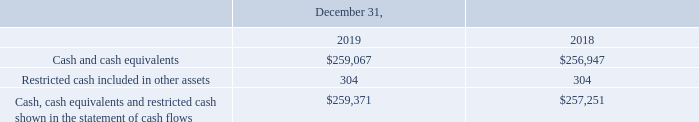Cash, Cash Equivalents and Restricted Cash
As of December 31, 2019, the Company had $259.1 million of cash and cash equivalents. Cash and cash equivalents include liquid investments, primarily money market funds, with maturities of less than 90 days at the time of purchase. Management determines the appropriate classification of its investments at the time of purchase and at each balance sheet date.
As of December 31, 2019 and December 31, 2018, the Company had restricted cash of $0.3 million, representing the amount pledged as collateral to the issuer of a standby letter of credit (the “LC”). The LC, which expires in August 2021, has been provided as a guaranty to the lessor of our corporate offices.
The following table provides a reconciliation of cash, cash equivalents and restricted cash reported within the consolidated balance sheet to the consolidated statement of cash flows (in thousands):
What are the respective cash and cash equivalents in 2018 and 2019?
Answer scale should be: thousand. $256,947, $259,067. What are the respective restricted cash included in other assets in 2018 and 2019?
Answer scale should be: thousand. 304, 304. What are the respective cash, cash equivalents and restricted cash shown in the statement of cash flows in 2018 and 2019?
Answer scale should be: thousand. $257,251, $259,371. What is the average cash and cash equivalents in 2018 and 2019?
Answer scale should be: thousand. ($259,067 + $256,947)/2 
Answer: 258007. What is the percentage change in cash and cash equivalents between 2018 and 2019?
Answer scale should be: percent. (259,067 - 256,947)/256,947 
Answer: 0.83. What is the percentage change in the cash, cash equivalents and restricted cash shown in the statement of cash flows between 2018 and 2019?
Answer scale should be: percent. (259,371 - 257,251)/257,251 
Answer: 0.82. 